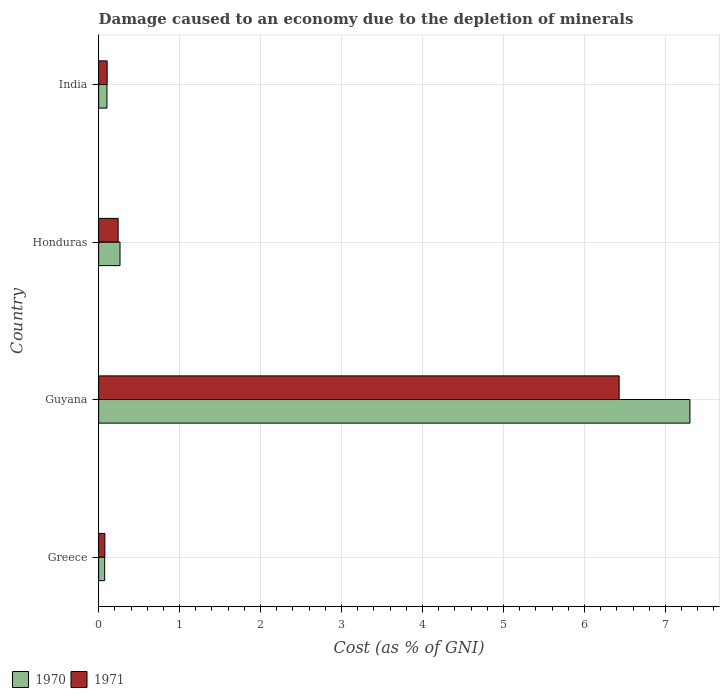How many different coloured bars are there?
Give a very brief answer. 2. How many groups of bars are there?
Your answer should be compact. 4. Are the number of bars on each tick of the Y-axis equal?
Keep it short and to the point. Yes. How many bars are there on the 4th tick from the bottom?
Your answer should be very brief. 2. What is the label of the 2nd group of bars from the top?
Keep it short and to the point. Honduras. What is the cost of damage caused due to the depletion of minerals in 1970 in Honduras?
Your answer should be compact. 0.26. Across all countries, what is the maximum cost of damage caused due to the depletion of minerals in 1970?
Your response must be concise. 7.3. Across all countries, what is the minimum cost of damage caused due to the depletion of minerals in 1970?
Your answer should be compact. 0.07. In which country was the cost of damage caused due to the depletion of minerals in 1971 maximum?
Your answer should be very brief. Guyana. In which country was the cost of damage caused due to the depletion of minerals in 1970 minimum?
Offer a very short reply. Greece. What is the total cost of damage caused due to the depletion of minerals in 1970 in the graph?
Your answer should be compact. 7.74. What is the difference between the cost of damage caused due to the depletion of minerals in 1971 in Guyana and that in India?
Your answer should be very brief. 6.32. What is the difference between the cost of damage caused due to the depletion of minerals in 1970 in Honduras and the cost of damage caused due to the depletion of minerals in 1971 in India?
Your response must be concise. 0.16. What is the average cost of damage caused due to the depletion of minerals in 1971 per country?
Give a very brief answer. 1.71. What is the difference between the cost of damage caused due to the depletion of minerals in 1971 and cost of damage caused due to the depletion of minerals in 1970 in Greece?
Your answer should be compact. 0. What is the ratio of the cost of damage caused due to the depletion of minerals in 1970 in Guyana to that in India?
Ensure brevity in your answer.  70.79. What is the difference between the highest and the second highest cost of damage caused due to the depletion of minerals in 1971?
Your response must be concise. 6.19. What is the difference between the highest and the lowest cost of damage caused due to the depletion of minerals in 1971?
Provide a short and direct response. 6.35. Is the sum of the cost of damage caused due to the depletion of minerals in 1970 in Greece and Honduras greater than the maximum cost of damage caused due to the depletion of minerals in 1971 across all countries?
Your answer should be compact. No. What does the 1st bar from the top in Guyana represents?
Make the answer very short. 1971. What does the 2nd bar from the bottom in India represents?
Your answer should be very brief. 1971. Are all the bars in the graph horizontal?
Ensure brevity in your answer.  Yes. How many countries are there in the graph?
Offer a very short reply. 4. Does the graph contain any zero values?
Give a very brief answer. No. Where does the legend appear in the graph?
Your response must be concise. Bottom left. What is the title of the graph?
Offer a very short reply. Damage caused to an economy due to the depletion of minerals. What is the label or title of the X-axis?
Provide a short and direct response. Cost (as % of GNI). What is the label or title of the Y-axis?
Provide a short and direct response. Country. What is the Cost (as % of GNI) of 1970 in Greece?
Give a very brief answer. 0.07. What is the Cost (as % of GNI) in 1971 in Greece?
Make the answer very short. 0.08. What is the Cost (as % of GNI) in 1970 in Guyana?
Provide a short and direct response. 7.3. What is the Cost (as % of GNI) in 1971 in Guyana?
Give a very brief answer. 6.43. What is the Cost (as % of GNI) in 1970 in Honduras?
Provide a succinct answer. 0.26. What is the Cost (as % of GNI) in 1971 in Honduras?
Provide a short and direct response. 0.24. What is the Cost (as % of GNI) in 1970 in India?
Provide a succinct answer. 0.1. What is the Cost (as % of GNI) in 1971 in India?
Your answer should be compact. 0.11. Across all countries, what is the maximum Cost (as % of GNI) in 1970?
Provide a succinct answer. 7.3. Across all countries, what is the maximum Cost (as % of GNI) of 1971?
Offer a terse response. 6.43. Across all countries, what is the minimum Cost (as % of GNI) in 1970?
Keep it short and to the point. 0.07. Across all countries, what is the minimum Cost (as % of GNI) of 1971?
Your answer should be very brief. 0.08. What is the total Cost (as % of GNI) of 1970 in the graph?
Provide a short and direct response. 7.74. What is the total Cost (as % of GNI) of 1971 in the graph?
Give a very brief answer. 6.85. What is the difference between the Cost (as % of GNI) of 1970 in Greece and that in Guyana?
Provide a succinct answer. -7.23. What is the difference between the Cost (as % of GNI) of 1971 in Greece and that in Guyana?
Keep it short and to the point. -6.35. What is the difference between the Cost (as % of GNI) in 1970 in Greece and that in Honduras?
Your response must be concise. -0.19. What is the difference between the Cost (as % of GNI) of 1971 in Greece and that in Honduras?
Your response must be concise. -0.16. What is the difference between the Cost (as % of GNI) of 1970 in Greece and that in India?
Your answer should be compact. -0.03. What is the difference between the Cost (as % of GNI) of 1971 in Greece and that in India?
Give a very brief answer. -0.03. What is the difference between the Cost (as % of GNI) in 1970 in Guyana and that in Honduras?
Ensure brevity in your answer.  7.04. What is the difference between the Cost (as % of GNI) of 1971 in Guyana and that in Honduras?
Provide a short and direct response. 6.19. What is the difference between the Cost (as % of GNI) in 1970 in Guyana and that in India?
Your response must be concise. 7.2. What is the difference between the Cost (as % of GNI) of 1971 in Guyana and that in India?
Provide a succinct answer. 6.32. What is the difference between the Cost (as % of GNI) of 1970 in Honduras and that in India?
Offer a very short reply. 0.16. What is the difference between the Cost (as % of GNI) of 1971 in Honduras and that in India?
Your response must be concise. 0.14. What is the difference between the Cost (as % of GNI) of 1970 in Greece and the Cost (as % of GNI) of 1971 in Guyana?
Make the answer very short. -6.35. What is the difference between the Cost (as % of GNI) in 1970 in Greece and the Cost (as % of GNI) in 1971 in Honduras?
Provide a short and direct response. -0.17. What is the difference between the Cost (as % of GNI) of 1970 in Greece and the Cost (as % of GNI) of 1971 in India?
Provide a succinct answer. -0.03. What is the difference between the Cost (as % of GNI) in 1970 in Guyana and the Cost (as % of GNI) in 1971 in Honduras?
Keep it short and to the point. 7.06. What is the difference between the Cost (as % of GNI) in 1970 in Guyana and the Cost (as % of GNI) in 1971 in India?
Offer a very short reply. 7.2. What is the difference between the Cost (as % of GNI) in 1970 in Honduras and the Cost (as % of GNI) in 1971 in India?
Make the answer very short. 0.16. What is the average Cost (as % of GNI) of 1970 per country?
Your response must be concise. 1.94. What is the average Cost (as % of GNI) of 1971 per country?
Provide a short and direct response. 1.71. What is the difference between the Cost (as % of GNI) in 1970 and Cost (as % of GNI) in 1971 in Greece?
Provide a succinct answer. -0. What is the difference between the Cost (as % of GNI) in 1970 and Cost (as % of GNI) in 1971 in Guyana?
Make the answer very short. 0.87. What is the difference between the Cost (as % of GNI) in 1970 and Cost (as % of GNI) in 1971 in Honduras?
Make the answer very short. 0.02. What is the difference between the Cost (as % of GNI) in 1970 and Cost (as % of GNI) in 1971 in India?
Make the answer very short. -0. What is the ratio of the Cost (as % of GNI) of 1970 in Greece to that in Guyana?
Keep it short and to the point. 0.01. What is the ratio of the Cost (as % of GNI) of 1971 in Greece to that in Guyana?
Your answer should be very brief. 0.01. What is the ratio of the Cost (as % of GNI) in 1970 in Greece to that in Honduras?
Offer a very short reply. 0.28. What is the ratio of the Cost (as % of GNI) of 1971 in Greece to that in Honduras?
Your answer should be compact. 0.32. What is the ratio of the Cost (as % of GNI) of 1970 in Greece to that in India?
Your answer should be very brief. 0.72. What is the ratio of the Cost (as % of GNI) in 1971 in Greece to that in India?
Give a very brief answer. 0.73. What is the ratio of the Cost (as % of GNI) of 1970 in Guyana to that in Honduras?
Your answer should be very brief. 27.66. What is the ratio of the Cost (as % of GNI) of 1971 in Guyana to that in Honduras?
Keep it short and to the point. 26.68. What is the ratio of the Cost (as % of GNI) of 1970 in Guyana to that in India?
Keep it short and to the point. 70.79. What is the ratio of the Cost (as % of GNI) in 1971 in Guyana to that in India?
Ensure brevity in your answer.  60.94. What is the ratio of the Cost (as % of GNI) in 1970 in Honduras to that in India?
Give a very brief answer. 2.56. What is the ratio of the Cost (as % of GNI) in 1971 in Honduras to that in India?
Provide a short and direct response. 2.28. What is the difference between the highest and the second highest Cost (as % of GNI) of 1970?
Offer a terse response. 7.04. What is the difference between the highest and the second highest Cost (as % of GNI) in 1971?
Provide a succinct answer. 6.19. What is the difference between the highest and the lowest Cost (as % of GNI) of 1970?
Your response must be concise. 7.23. What is the difference between the highest and the lowest Cost (as % of GNI) of 1971?
Provide a short and direct response. 6.35. 